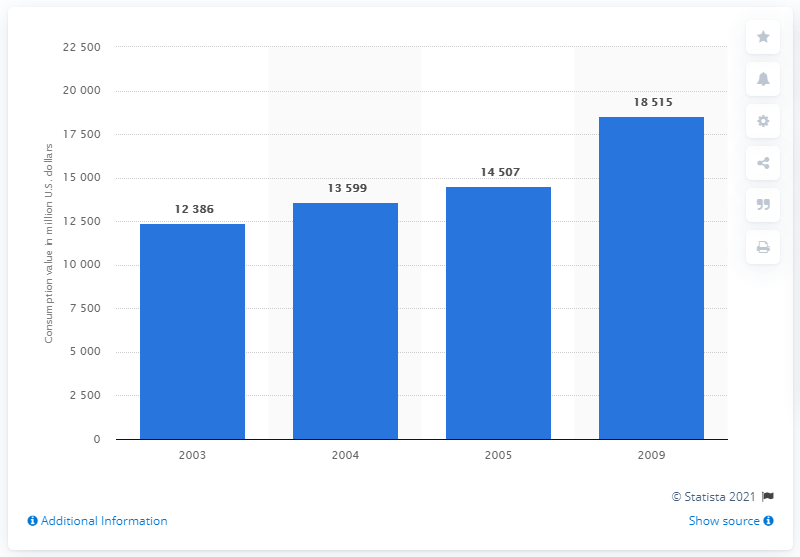Draw attention to some important aspects in this diagram. In 2009, the amount of cosmetic packaging consumed in the United States was 18,515 metric tons. 